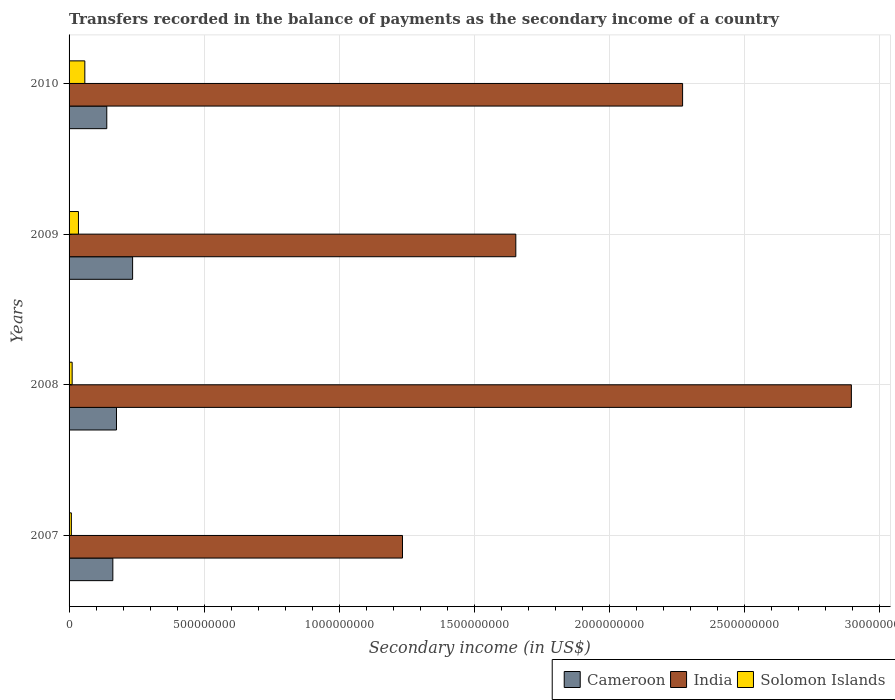How many groups of bars are there?
Ensure brevity in your answer.  4. Are the number of bars per tick equal to the number of legend labels?
Your answer should be compact. Yes. How many bars are there on the 4th tick from the top?
Your response must be concise. 3. How many bars are there on the 4th tick from the bottom?
Ensure brevity in your answer.  3. In how many cases, is the number of bars for a given year not equal to the number of legend labels?
Offer a terse response. 0. What is the secondary income of in Cameroon in 2010?
Offer a terse response. 1.40e+08. Across all years, what is the maximum secondary income of in Solomon Islands?
Keep it short and to the point. 5.83e+07. Across all years, what is the minimum secondary income of in Solomon Islands?
Offer a very short reply. 8.44e+06. In which year was the secondary income of in India maximum?
Offer a very short reply. 2008. What is the total secondary income of in Solomon Islands in the graph?
Give a very brief answer. 1.13e+08. What is the difference between the secondary income of in Cameroon in 2007 and that in 2009?
Your answer should be very brief. -7.31e+07. What is the difference between the secondary income of in India in 2010 and the secondary income of in Solomon Islands in 2007?
Your answer should be very brief. 2.26e+09. What is the average secondary income of in Solomon Islands per year?
Offer a very short reply. 2.82e+07. In the year 2008, what is the difference between the secondary income of in Solomon Islands and secondary income of in India?
Offer a very short reply. -2.88e+09. What is the ratio of the secondary income of in India in 2008 to that in 2010?
Give a very brief answer. 1.28. Is the difference between the secondary income of in Solomon Islands in 2007 and 2010 greater than the difference between the secondary income of in India in 2007 and 2010?
Provide a succinct answer. Yes. What is the difference between the highest and the second highest secondary income of in India?
Provide a succinct answer. 6.25e+08. What is the difference between the highest and the lowest secondary income of in Solomon Islands?
Your response must be concise. 4.99e+07. Is the sum of the secondary income of in India in 2008 and 2010 greater than the maximum secondary income of in Cameroon across all years?
Offer a very short reply. Yes. What does the 1st bar from the top in 2010 represents?
Offer a terse response. Solomon Islands. What does the 1st bar from the bottom in 2007 represents?
Your response must be concise. Cameroon. Is it the case that in every year, the sum of the secondary income of in India and secondary income of in Cameroon is greater than the secondary income of in Solomon Islands?
Your response must be concise. Yes. How many bars are there?
Offer a terse response. 12. Are all the bars in the graph horizontal?
Your answer should be very brief. Yes. How many years are there in the graph?
Keep it short and to the point. 4. Does the graph contain any zero values?
Keep it short and to the point. No. Where does the legend appear in the graph?
Provide a succinct answer. Bottom right. How many legend labels are there?
Provide a short and direct response. 3. What is the title of the graph?
Give a very brief answer. Transfers recorded in the balance of payments as the secondary income of a country. Does "Portugal" appear as one of the legend labels in the graph?
Give a very brief answer. No. What is the label or title of the X-axis?
Give a very brief answer. Secondary income (in US$). What is the label or title of the Y-axis?
Ensure brevity in your answer.  Years. What is the Secondary income (in US$) in Cameroon in 2007?
Provide a succinct answer. 1.62e+08. What is the Secondary income (in US$) in India in 2007?
Your response must be concise. 1.23e+09. What is the Secondary income (in US$) of Solomon Islands in 2007?
Your answer should be very brief. 8.44e+06. What is the Secondary income (in US$) in Cameroon in 2008?
Give a very brief answer. 1.75e+08. What is the Secondary income (in US$) of India in 2008?
Provide a succinct answer. 2.89e+09. What is the Secondary income (in US$) of Solomon Islands in 2008?
Your answer should be compact. 1.14e+07. What is the Secondary income (in US$) of Cameroon in 2009?
Offer a terse response. 2.35e+08. What is the Secondary income (in US$) of India in 2009?
Give a very brief answer. 1.65e+09. What is the Secondary income (in US$) of Solomon Islands in 2009?
Give a very brief answer. 3.47e+07. What is the Secondary income (in US$) in Cameroon in 2010?
Offer a terse response. 1.40e+08. What is the Secondary income (in US$) of India in 2010?
Offer a very short reply. 2.27e+09. What is the Secondary income (in US$) of Solomon Islands in 2010?
Ensure brevity in your answer.  5.83e+07. Across all years, what is the maximum Secondary income (in US$) in Cameroon?
Keep it short and to the point. 2.35e+08. Across all years, what is the maximum Secondary income (in US$) of India?
Provide a short and direct response. 2.89e+09. Across all years, what is the maximum Secondary income (in US$) in Solomon Islands?
Make the answer very short. 5.83e+07. Across all years, what is the minimum Secondary income (in US$) in Cameroon?
Your response must be concise. 1.40e+08. Across all years, what is the minimum Secondary income (in US$) of India?
Give a very brief answer. 1.23e+09. Across all years, what is the minimum Secondary income (in US$) of Solomon Islands?
Your answer should be very brief. 8.44e+06. What is the total Secondary income (in US$) of Cameroon in the graph?
Offer a terse response. 7.12e+08. What is the total Secondary income (in US$) of India in the graph?
Ensure brevity in your answer.  8.05e+09. What is the total Secondary income (in US$) of Solomon Islands in the graph?
Your answer should be compact. 1.13e+08. What is the difference between the Secondary income (in US$) in Cameroon in 2007 and that in 2008?
Provide a short and direct response. -1.34e+07. What is the difference between the Secondary income (in US$) of India in 2007 and that in 2008?
Your answer should be compact. -1.66e+09. What is the difference between the Secondary income (in US$) in Solomon Islands in 2007 and that in 2008?
Your response must be concise. -2.95e+06. What is the difference between the Secondary income (in US$) in Cameroon in 2007 and that in 2009?
Keep it short and to the point. -7.31e+07. What is the difference between the Secondary income (in US$) in India in 2007 and that in 2009?
Your answer should be compact. -4.19e+08. What is the difference between the Secondary income (in US$) in Solomon Islands in 2007 and that in 2009?
Offer a very short reply. -2.62e+07. What is the difference between the Secondary income (in US$) in Cameroon in 2007 and that in 2010?
Ensure brevity in your answer.  2.24e+07. What is the difference between the Secondary income (in US$) in India in 2007 and that in 2010?
Provide a succinct answer. -1.04e+09. What is the difference between the Secondary income (in US$) in Solomon Islands in 2007 and that in 2010?
Keep it short and to the point. -4.99e+07. What is the difference between the Secondary income (in US$) of Cameroon in 2008 and that in 2009?
Your response must be concise. -5.97e+07. What is the difference between the Secondary income (in US$) of India in 2008 and that in 2009?
Make the answer very short. 1.24e+09. What is the difference between the Secondary income (in US$) in Solomon Islands in 2008 and that in 2009?
Make the answer very short. -2.33e+07. What is the difference between the Secondary income (in US$) in Cameroon in 2008 and that in 2010?
Your response must be concise. 3.59e+07. What is the difference between the Secondary income (in US$) in India in 2008 and that in 2010?
Offer a terse response. 6.25e+08. What is the difference between the Secondary income (in US$) of Solomon Islands in 2008 and that in 2010?
Ensure brevity in your answer.  -4.69e+07. What is the difference between the Secondary income (in US$) of Cameroon in 2009 and that in 2010?
Ensure brevity in your answer.  9.56e+07. What is the difference between the Secondary income (in US$) of India in 2009 and that in 2010?
Give a very brief answer. -6.17e+08. What is the difference between the Secondary income (in US$) of Solomon Islands in 2009 and that in 2010?
Give a very brief answer. -2.36e+07. What is the difference between the Secondary income (in US$) of Cameroon in 2007 and the Secondary income (in US$) of India in 2008?
Your answer should be very brief. -2.73e+09. What is the difference between the Secondary income (in US$) in Cameroon in 2007 and the Secondary income (in US$) in Solomon Islands in 2008?
Your answer should be very brief. 1.51e+08. What is the difference between the Secondary income (in US$) in India in 2007 and the Secondary income (in US$) in Solomon Islands in 2008?
Offer a terse response. 1.22e+09. What is the difference between the Secondary income (in US$) in Cameroon in 2007 and the Secondary income (in US$) in India in 2009?
Your answer should be very brief. -1.49e+09. What is the difference between the Secondary income (in US$) in Cameroon in 2007 and the Secondary income (in US$) in Solomon Islands in 2009?
Give a very brief answer. 1.27e+08. What is the difference between the Secondary income (in US$) of India in 2007 and the Secondary income (in US$) of Solomon Islands in 2009?
Give a very brief answer. 1.20e+09. What is the difference between the Secondary income (in US$) in Cameroon in 2007 and the Secondary income (in US$) in India in 2010?
Your response must be concise. -2.11e+09. What is the difference between the Secondary income (in US$) of Cameroon in 2007 and the Secondary income (in US$) of Solomon Islands in 2010?
Offer a very short reply. 1.04e+08. What is the difference between the Secondary income (in US$) of India in 2007 and the Secondary income (in US$) of Solomon Islands in 2010?
Your answer should be very brief. 1.18e+09. What is the difference between the Secondary income (in US$) of Cameroon in 2008 and the Secondary income (in US$) of India in 2009?
Keep it short and to the point. -1.48e+09. What is the difference between the Secondary income (in US$) of Cameroon in 2008 and the Secondary income (in US$) of Solomon Islands in 2009?
Offer a terse response. 1.41e+08. What is the difference between the Secondary income (in US$) of India in 2008 and the Secondary income (in US$) of Solomon Islands in 2009?
Offer a very short reply. 2.86e+09. What is the difference between the Secondary income (in US$) in Cameroon in 2008 and the Secondary income (in US$) in India in 2010?
Your response must be concise. -2.09e+09. What is the difference between the Secondary income (in US$) of Cameroon in 2008 and the Secondary income (in US$) of Solomon Islands in 2010?
Provide a succinct answer. 1.17e+08. What is the difference between the Secondary income (in US$) in India in 2008 and the Secondary income (in US$) in Solomon Islands in 2010?
Give a very brief answer. 2.84e+09. What is the difference between the Secondary income (in US$) of Cameroon in 2009 and the Secondary income (in US$) of India in 2010?
Your answer should be compact. -2.03e+09. What is the difference between the Secondary income (in US$) of Cameroon in 2009 and the Secondary income (in US$) of Solomon Islands in 2010?
Provide a short and direct response. 1.77e+08. What is the difference between the Secondary income (in US$) in India in 2009 and the Secondary income (in US$) in Solomon Islands in 2010?
Ensure brevity in your answer.  1.59e+09. What is the average Secondary income (in US$) of Cameroon per year?
Give a very brief answer. 1.78e+08. What is the average Secondary income (in US$) in India per year?
Ensure brevity in your answer.  2.01e+09. What is the average Secondary income (in US$) of Solomon Islands per year?
Your answer should be very brief. 2.82e+07. In the year 2007, what is the difference between the Secondary income (in US$) in Cameroon and Secondary income (in US$) in India?
Offer a very short reply. -1.07e+09. In the year 2007, what is the difference between the Secondary income (in US$) in Cameroon and Secondary income (in US$) in Solomon Islands?
Provide a succinct answer. 1.54e+08. In the year 2007, what is the difference between the Secondary income (in US$) in India and Secondary income (in US$) in Solomon Islands?
Offer a very short reply. 1.23e+09. In the year 2008, what is the difference between the Secondary income (in US$) of Cameroon and Secondary income (in US$) of India?
Offer a very short reply. -2.72e+09. In the year 2008, what is the difference between the Secondary income (in US$) in Cameroon and Secondary income (in US$) in Solomon Islands?
Your answer should be very brief. 1.64e+08. In the year 2008, what is the difference between the Secondary income (in US$) in India and Secondary income (in US$) in Solomon Islands?
Offer a terse response. 2.88e+09. In the year 2009, what is the difference between the Secondary income (in US$) in Cameroon and Secondary income (in US$) in India?
Your answer should be very brief. -1.42e+09. In the year 2009, what is the difference between the Secondary income (in US$) in Cameroon and Secondary income (in US$) in Solomon Islands?
Keep it short and to the point. 2.00e+08. In the year 2009, what is the difference between the Secondary income (in US$) in India and Secondary income (in US$) in Solomon Islands?
Provide a succinct answer. 1.62e+09. In the year 2010, what is the difference between the Secondary income (in US$) of Cameroon and Secondary income (in US$) of India?
Provide a succinct answer. -2.13e+09. In the year 2010, what is the difference between the Secondary income (in US$) in Cameroon and Secondary income (in US$) in Solomon Islands?
Ensure brevity in your answer.  8.12e+07. In the year 2010, what is the difference between the Secondary income (in US$) of India and Secondary income (in US$) of Solomon Islands?
Offer a terse response. 2.21e+09. What is the ratio of the Secondary income (in US$) in Cameroon in 2007 to that in 2008?
Keep it short and to the point. 0.92. What is the ratio of the Secondary income (in US$) of India in 2007 to that in 2008?
Your answer should be compact. 0.43. What is the ratio of the Secondary income (in US$) of Solomon Islands in 2007 to that in 2008?
Your answer should be compact. 0.74. What is the ratio of the Secondary income (in US$) in Cameroon in 2007 to that in 2009?
Ensure brevity in your answer.  0.69. What is the ratio of the Secondary income (in US$) of India in 2007 to that in 2009?
Make the answer very short. 0.75. What is the ratio of the Secondary income (in US$) in Solomon Islands in 2007 to that in 2009?
Give a very brief answer. 0.24. What is the ratio of the Secondary income (in US$) in Cameroon in 2007 to that in 2010?
Your response must be concise. 1.16. What is the ratio of the Secondary income (in US$) in India in 2007 to that in 2010?
Your response must be concise. 0.54. What is the ratio of the Secondary income (in US$) of Solomon Islands in 2007 to that in 2010?
Provide a succinct answer. 0.14. What is the ratio of the Secondary income (in US$) of Cameroon in 2008 to that in 2009?
Make the answer very short. 0.75. What is the ratio of the Secondary income (in US$) in India in 2008 to that in 2009?
Give a very brief answer. 1.75. What is the ratio of the Secondary income (in US$) in Solomon Islands in 2008 to that in 2009?
Give a very brief answer. 0.33. What is the ratio of the Secondary income (in US$) of Cameroon in 2008 to that in 2010?
Keep it short and to the point. 1.26. What is the ratio of the Secondary income (in US$) of India in 2008 to that in 2010?
Your response must be concise. 1.28. What is the ratio of the Secondary income (in US$) in Solomon Islands in 2008 to that in 2010?
Keep it short and to the point. 0.2. What is the ratio of the Secondary income (in US$) in Cameroon in 2009 to that in 2010?
Your answer should be compact. 1.68. What is the ratio of the Secondary income (in US$) of India in 2009 to that in 2010?
Keep it short and to the point. 0.73. What is the ratio of the Secondary income (in US$) of Solomon Islands in 2009 to that in 2010?
Your answer should be compact. 0.6. What is the difference between the highest and the second highest Secondary income (in US$) of Cameroon?
Your answer should be compact. 5.97e+07. What is the difference between the highest and the second highest Secondary income (in US$) in India?
Make the answer very short. 6.25e+08. What is the difference between the highest and the second highest Secondary income (in US$) in Solomon Islands?
Offer a terse response. 2.36e+07. What is the difference between the highest and the lowest Secondary income (in US$) of Cameroon?
Ensure brevity in your answer.  9.56e+07. What is the difference between the highest and the lowest Secondary income (in US$) of India?
Your response must be concise. 1.66e+09. What is the difference between the highest and the lowest Secondary income (in US$) of Solomon Islands?
Your answer should be compact. 4.99e+07. 